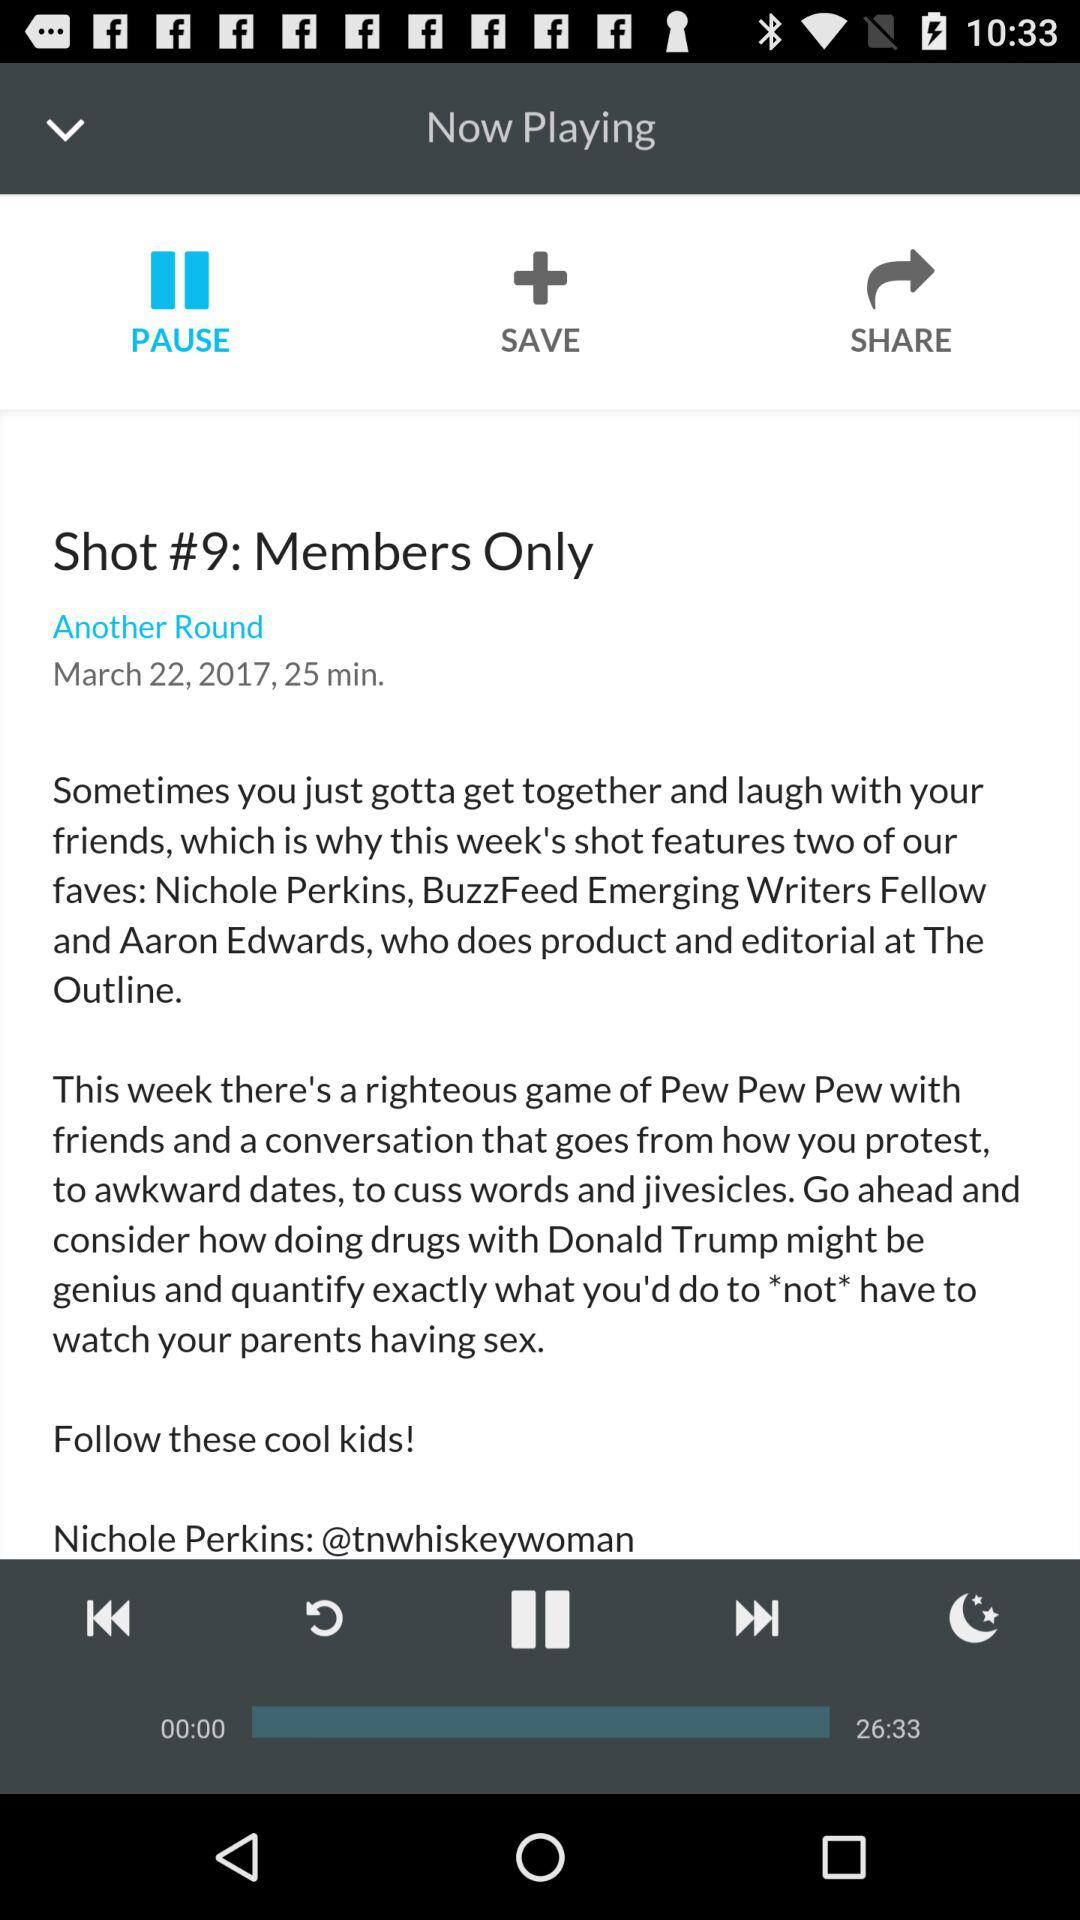What is the published date? The published date is March 22, 2017. 